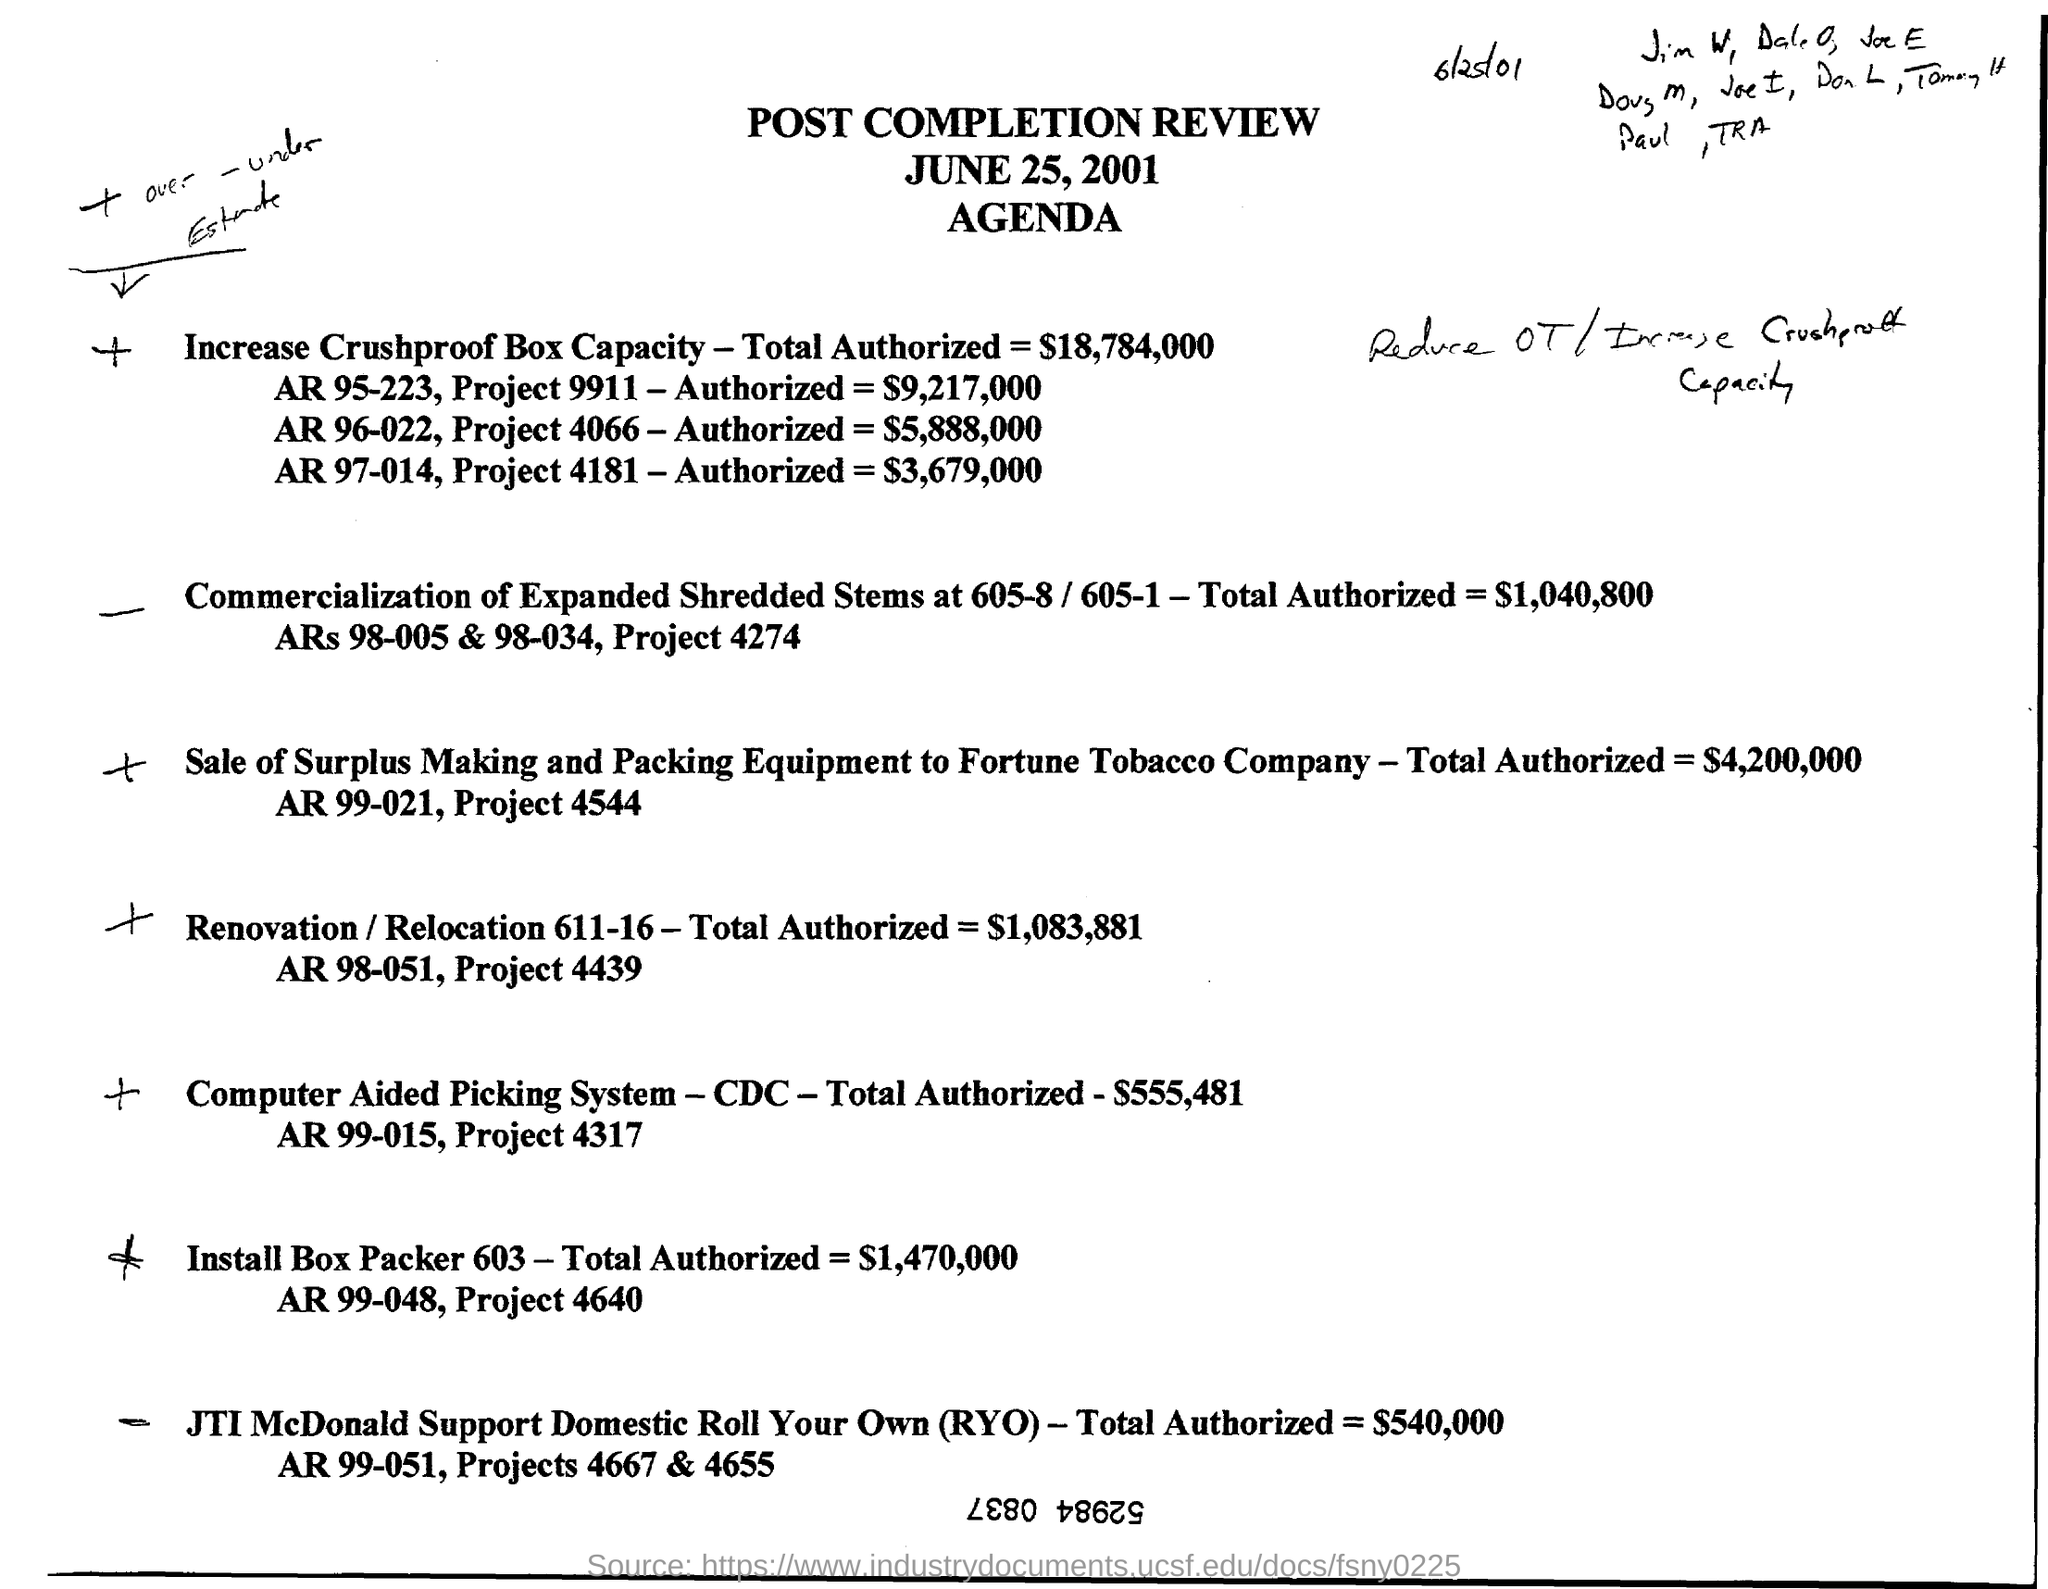Specify some key components in this picture. This review pertains to a post-completion review. Project 4439 involves renovating and potentially relocating a building at 611-16. The document is dated June 25, 2001. The total authorized amount for the Computer Aided Picking System is $555,481. 